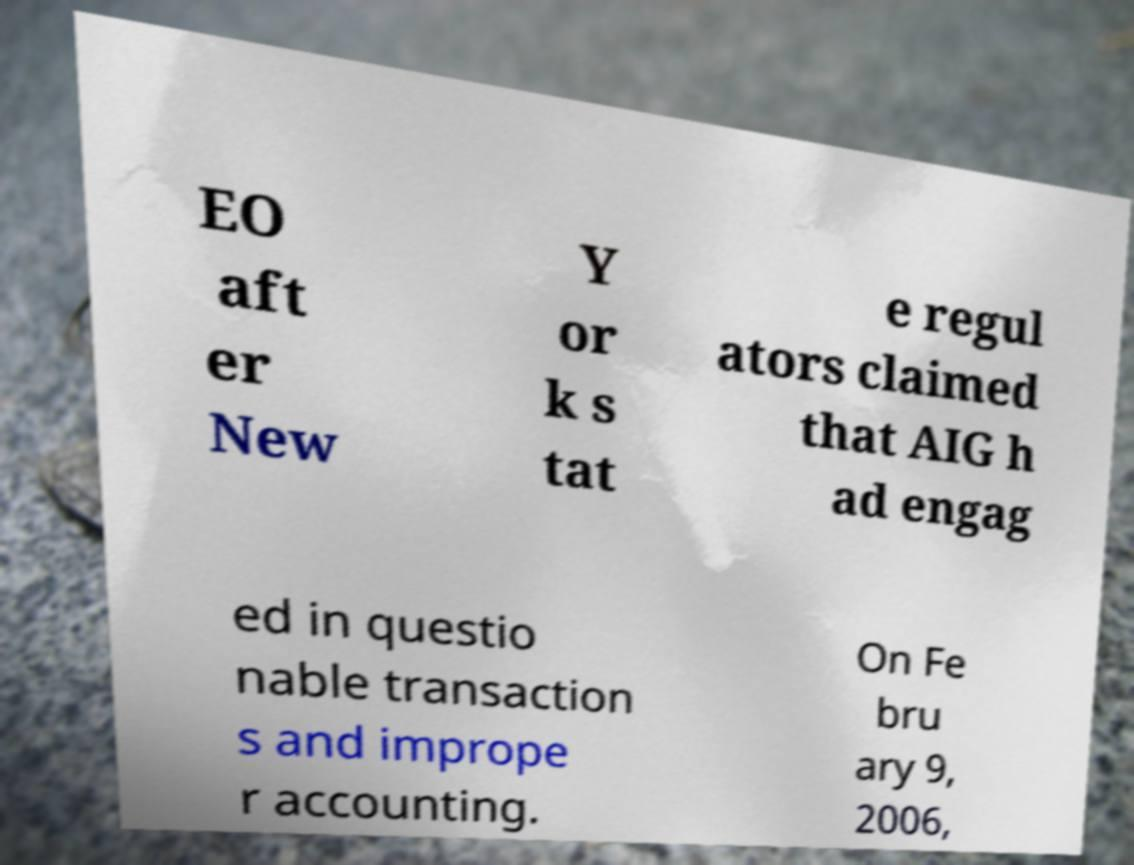There's text embedded in this image that I need extracted. Can you transcribe it verbatim? EO aft er New Y or k s tat e regul ators claimed that AIG h ad engag ed in questio nable transaction s and imprope r accounting. On Fe bru ary 9, 2006, 